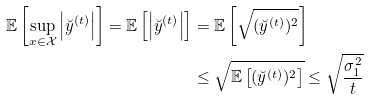Convert formula to latex. <formula><loc_0><loc_0><loc_500><loc_500>\mathbb { E } \left [ \sup _ { x \in \mathcal { X } } \left | \breve { y } ^ { ( t ) } \right | \right ] = \mathbb { E } \left [ \left | \breve { y } ^ { ( t ) } \right | \right ] & = \mathbb { E } \left [ \sqrt { ( \breve { y } ^ { ( t ) } ) ^ { 2 } } \right ] \\ & \leq \sqrt { \mathbb { E } \left [ ( \breve { y } ^ { ( t ) } ) ^ { 2 } \right ] } \leq \sqrt { \frac { \sigma _ { 1 } ^ { 2 } } { t } }</formula> 